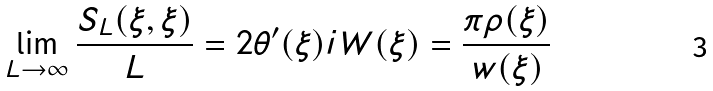<formula> <loc_0><loc_0><loc_500><loc_500>\lim _ { L \rightarrow \infty } \frac { S _ { L } ( \xi , \xi ) } { L } = 2 \theta ^ { \prime } ( \xi ) i W ( \xi ) = \frac { \pi \rho ( \xi ) } { w ( \xi ) }</formula> 